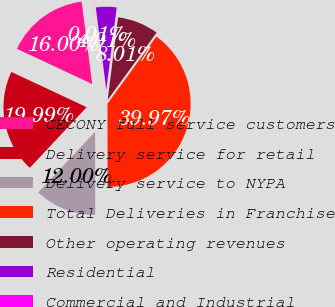Convert chart. <chart><loc_0><loc_0><loc_500><loc_500><pie_chart><fcel>CECONY full service customers<fcel>Delivery service for retail<fcel>Delivery service to NYPA<fcel>Total Deliveries in Franchise<fcel>Other operating revenues<fcel>Residential<fcel>Commercial and Industrial<nl><fcel>16.0%<fcel>19.99%<fcel>12.0%<fcel>39.97%<fcel>8.01%<fcel>4.01%<fcel>0.01%<nl></chart> 